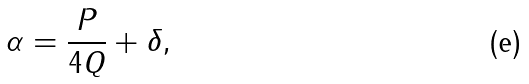<formula> <loc_0><loc_0><loc_500><loc_500>\alpha = \frac { P } { 4 Q } + \delta ,</formula> 